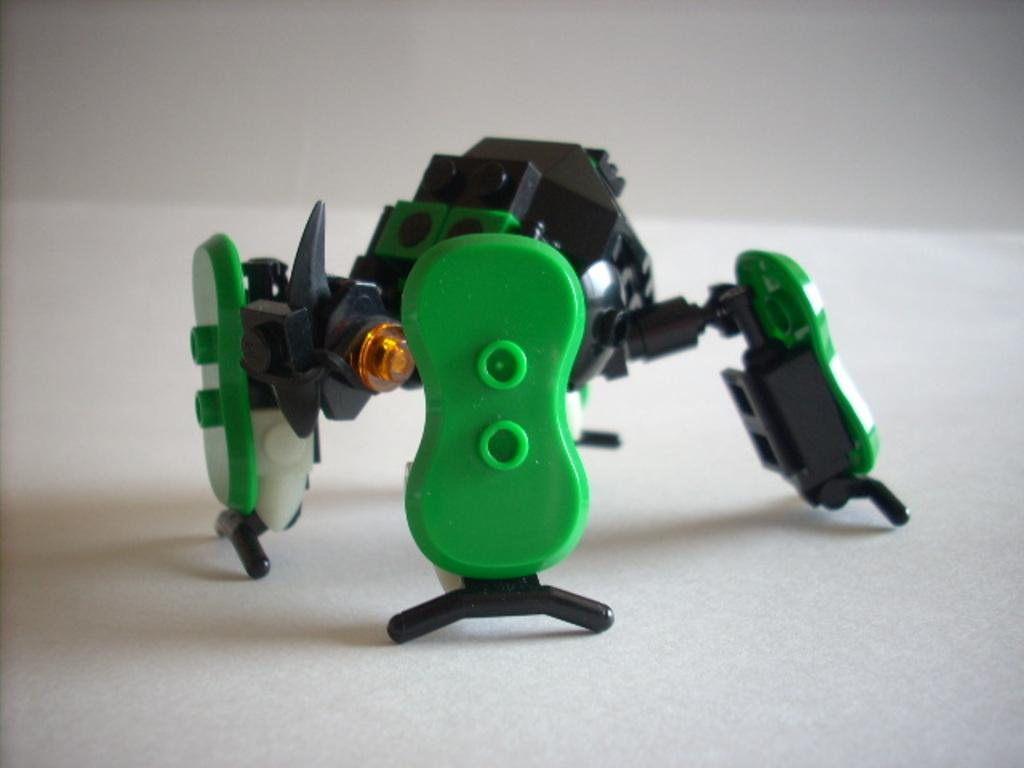What is the main object in the image? There is a toy in the image. What colors can be seen on the toy? The toy has green, black, and white colors. What else is present in the image besides the toy? There is a light in the image. What is the color of the surface the toy is placed on? The toy is on a white surface. What is the person's belief about the toy in the image? There is no person present in the image, so it is not possible to determine their belief about the toy. 